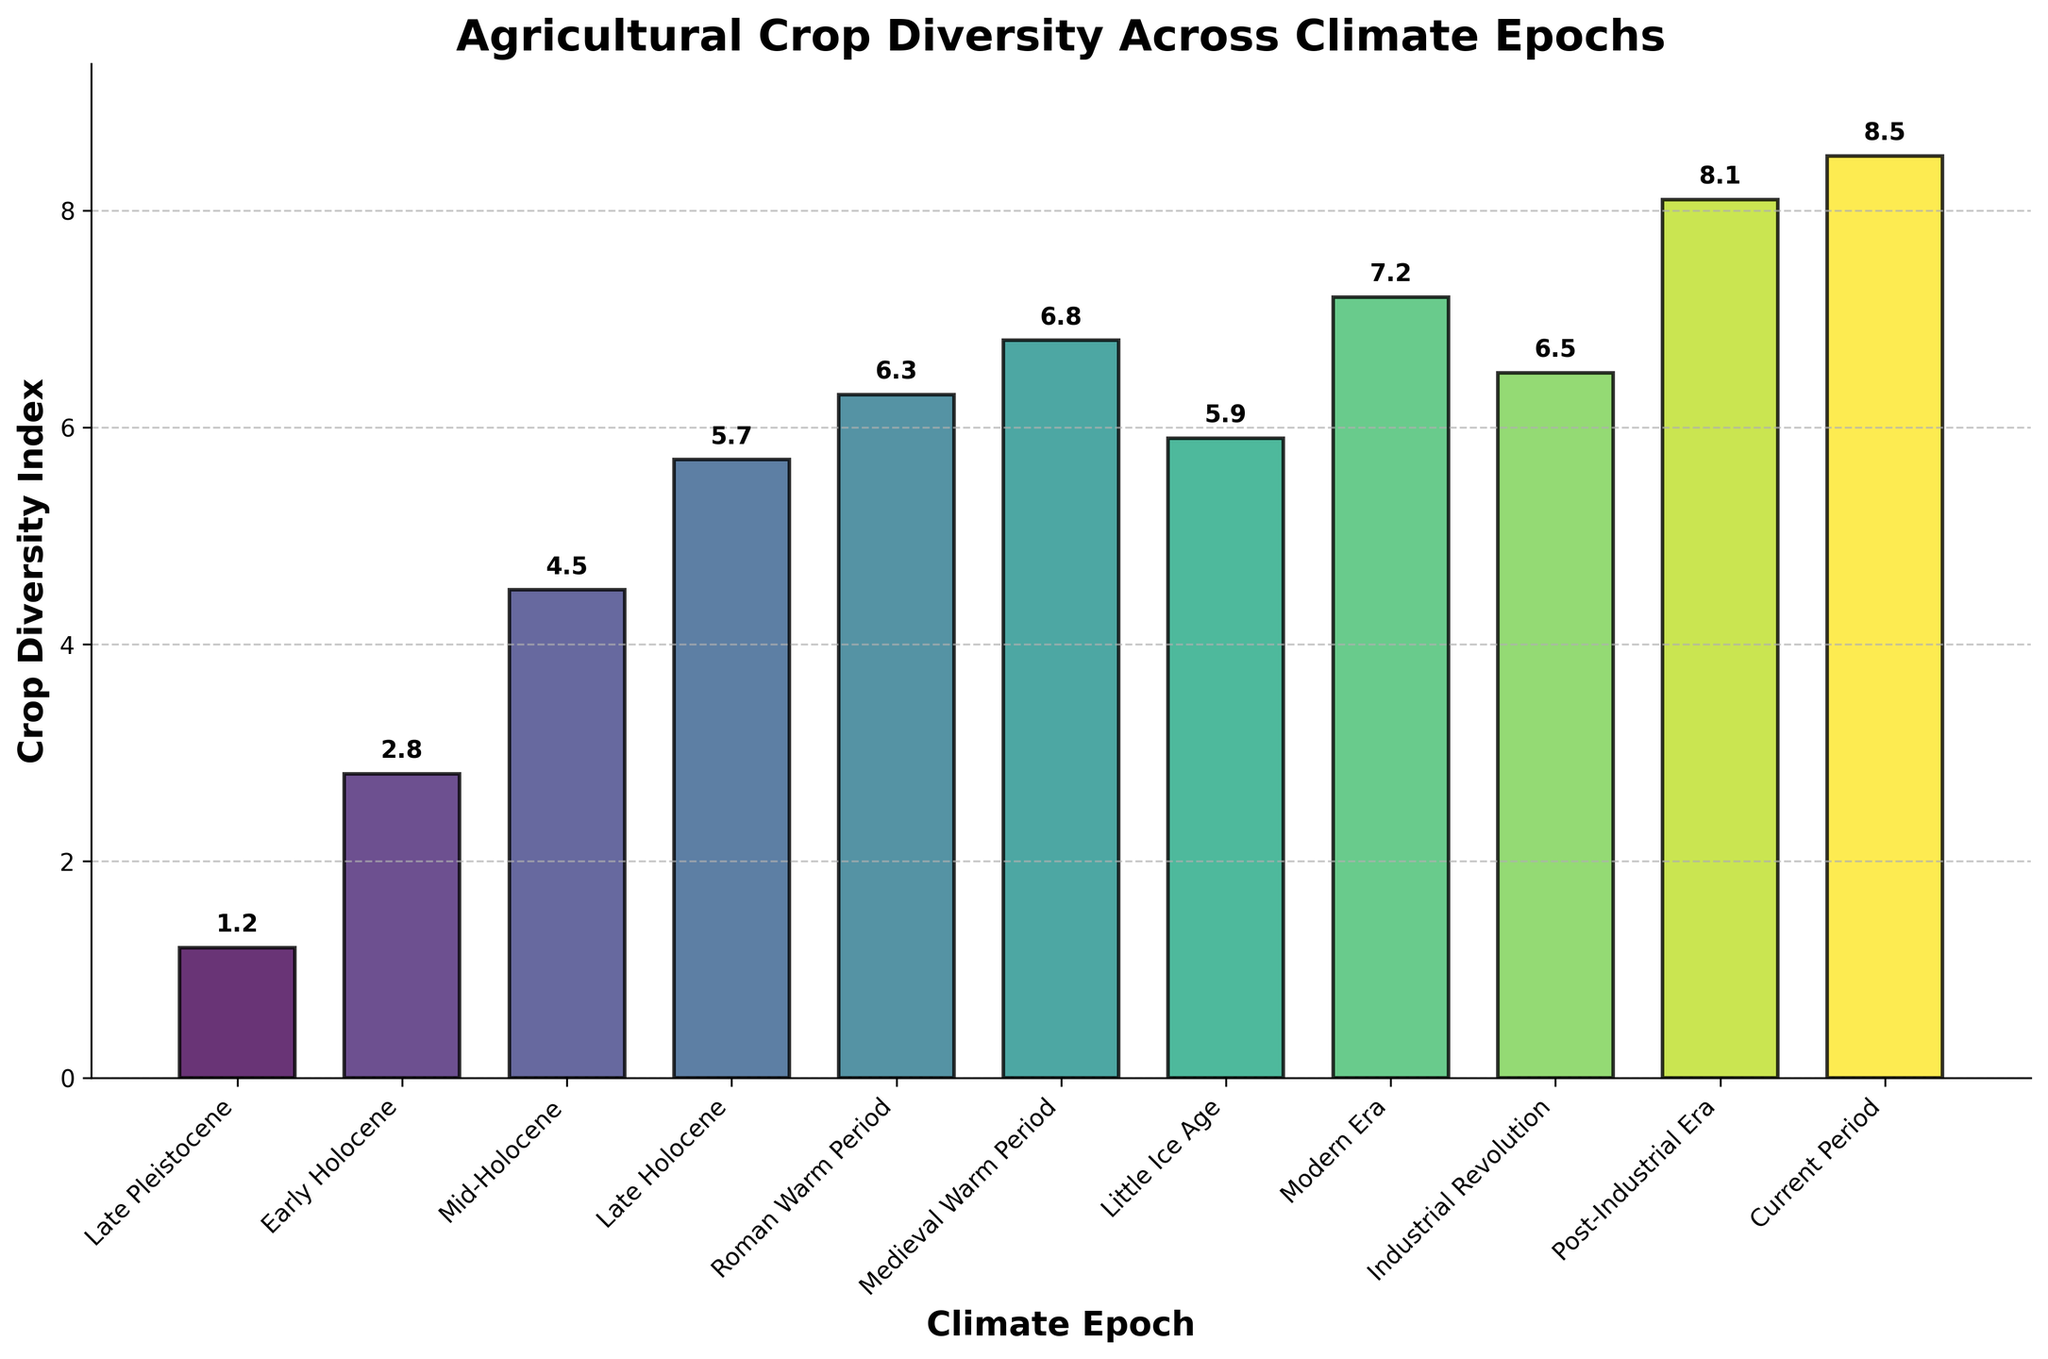What is the climate epoch with the highest Crop Diversity Index? The climate epoch with the highest Crop Diversity Index can be determined by observing the height of the bars. The tallest bar corresponds to the "Current Period," which has a Crop Diversity Index of 8.5.
Answer: Current Period Which two climate epochs have the smallest difference in Crop Diversity Index? To determine this, compare the Crop Diversity Index values for all neighboring epochs. The smallest difference occurs between the "Roman Warm Period" (6.3) and the "Medieval Warm Period" (6.8), with a difference of 0.5.
Answer: Roman Warm Period and Medieval Warm Period What is the Crop Diversity Index during the Late Holocene, and how does it compare to that of the Medieval Warm Period? The Crop Diversity Index during the Late Holocene is 5.7. For the Medieval Warm Period, it is 6.8. The Medieval Warm Period has a higher index by 1.1.
Answer: 5.7, Medieval Warm Period is higher by 1.1 What is the difference between the Crop Diversity Index of the Early Holocene and the Modern Era? The Crop Diversity Index of the Early Holocene is 2.8, while that of the Modern Era is 7.2. Subtracting the Early Holocene from the Modern Era: 7.2 - 2.8 = 4.4.
Answer: 4.4 What is the average Crop Diversity Index across all climate epochs shown? Sum the Crop Diversity Index values for all epochs: 1.2 + 2.8 + 4.5 + 5.7 + 6.3 + 6.8 + 5.9 + 7.2 + 6.5 + 8.1 + 8.5 = 63.5. There are 11 epochs, so the average is 63.5 / 11 ≈ 5.77.
Answer: 5.77 What is the Crop Diversity Index during the Industrial Revolution, and how visually distinct is it compared to the Late Pleistocene? The Crop Diversity Index during the Industrial Revolution is 6.5. The Late Pleistocene has an index of 1.2. Visually, the bar representing the Industrial Revolution is significantly taller.
Answer: 6.5, significantly taller Identify the climate epoch where the Crop Diversity Index exceeds 7.0. By examining the height of the bars, it is clear that the "Modern Era" (7.2), "Post-Industrial Era" (8.1), and "Current Period" (8.5) are the epochs where the index exceeds 7.0.
Answer: Modern Era, Post-Industrial Era, Current Period By how much did the Crop Diversity Index increase from the Mid-Holocene to the Late Holocene? The Crop Diversity Index for the Mid-Holocene is 4.5, and for the Late Holocene, it is 5.7. The increase is 5.7 - 4.5 = 1.2.
Answer: 1.2 How does the Crop Diversity Index in the Little Ice Age compare to that in the Roman Warm Period? The Crop Diversity Index in the Little Ice Age is 5.9, whereas it is 6.3 during the Roman Warm Period. The index decreases by 0.4 from the Roman Warm Period to the Little Ice Age.
Answer: Decreased by 0.4 